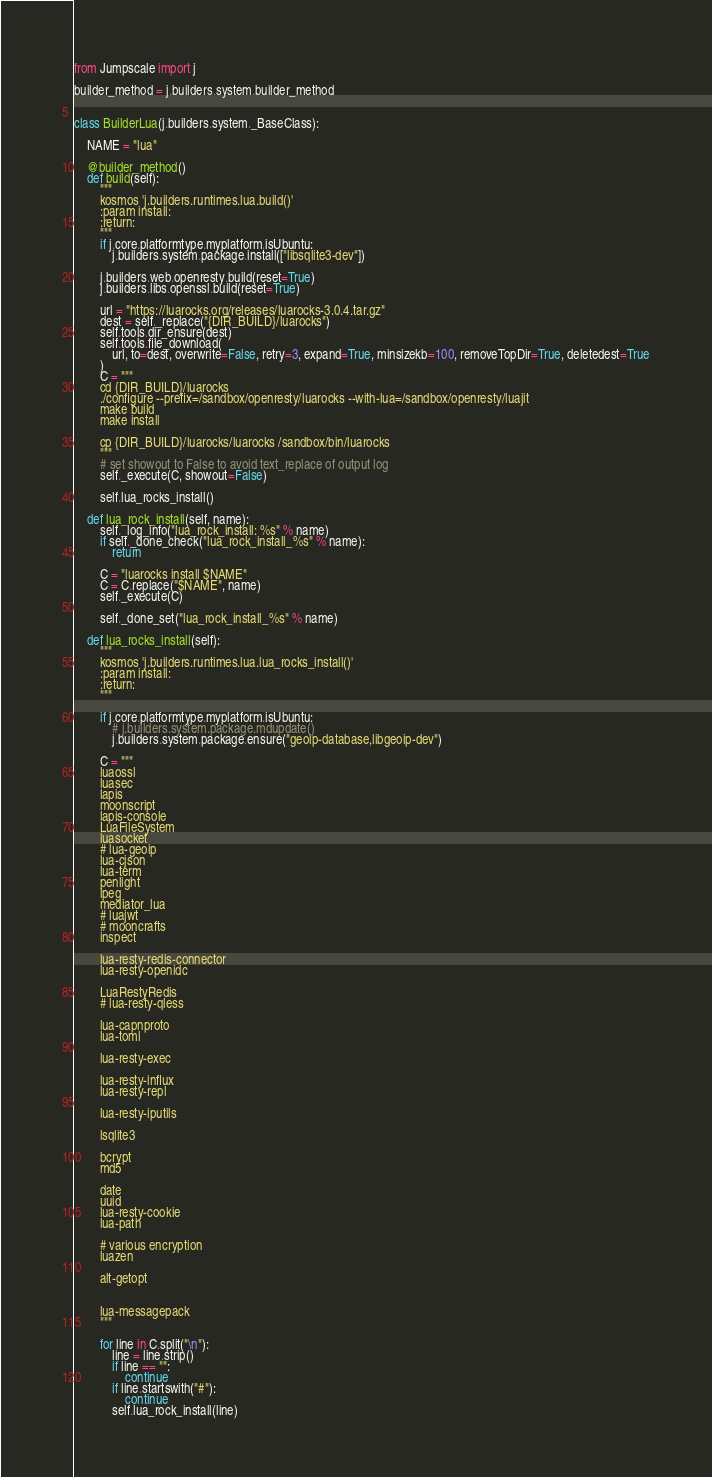Convert code to text. <code><loc_0><loc_0><loc_500><loc_500><_Python_>from Jumpscale import j

builder_method = j.builders.system.builder_method


class BuilderLua(j.builders.system._BaseClass):

    NAME = "lua"

    @builder_method()
    def build(self):
        """
        kosmos 'j.builders.runtimes.lua.build()'
        :param install:
        :return:
        """
        if j.core.platformtype.myplatform.isUbuntu:
            j.builders.system.package.install(["libsqlite3-dev"])

        j.builders.web.openresty.build(reset=True)
        j.builders.libs.openssl.build(reset=True)

        url = "https://luarocks.org/releases/luarocks-3.0.4.tar.gz"
        dest = self._replace("{DIR_BUILD}/luarocks")
        self.tools.dir_ensure(dest)
        self.tools.file_download(
            url, to=dest, overwrite=False, retry=3, expand=True, minsizekb=100, removeTopDir=True, deletedest=True
        )
        C = """
        cd {DIR_BUILD}/luarocks
        ./configure --prefix=/sandbox/openresty/luarocks --with-lua=/sandbox/openresty/luajit
        make build
        make install

        cp {DIR_BUILD}/luarocks/luarocks /sandbox/bin/luarocks
        """
        # set showout to False to avoid text_replace of output log
        self._execute(C, showout=False)

        self.lua_rocks_install()

    def lua_rock_install(self, name):
        self._log_info("lua_rock_install: %s" % name)
        if self._done_check("lua_rock_install_%s" % name):
            return

        C = "luarocks install $NAME"
        C = C.replace("$NAME", name)
        self._execute(C)

        self._done_set("lua_rock_install_%s" % name)

    def lua_rocks_install(self):
        """
        kosmos 'j.builders.runtimes.lua.lua_rocks_install()'
        :param install:
        :return:
        """

        if j.core.platformtype.myplatform.isUbuntu:
            # j.builders.system.package.mdupdate()
            j.builders.system.package.ensure("geoip-database,libgeoip-dev")

        C = """
        luaossl
        luasec
        lapis
        moonscript
        lapis-console
        LuaFileSystem
        luasocket
        # lua-geoip
        lua-cjson
        lua-term
        penlight
        lpeg
        mediator_lua
        # luajwt
        # mooncrafts
        inspect

        lua-resty-redis-connector
        lua-resty-openidc

        LuaRestyRedis
        # lua-resty-qless

        lua-capnproto
        lua-toml

        lua-resty-exec

        lua-resty-influx
        lua-resty-repl

        lua-resty-iputils

        lsqlite3

        bcrypt
        md5

        date
        uuid
        lua-resty-cookie
        lua-path

        # various encryption
        luazen

        alt-getopt


        lua-messagepack
        """

        for line in C.split("\n"):
            line = line.strip()
            if line == "":
                continue
            if line.startswith("#"):
                continue
            self.lua_rock_install(line)
</code> 